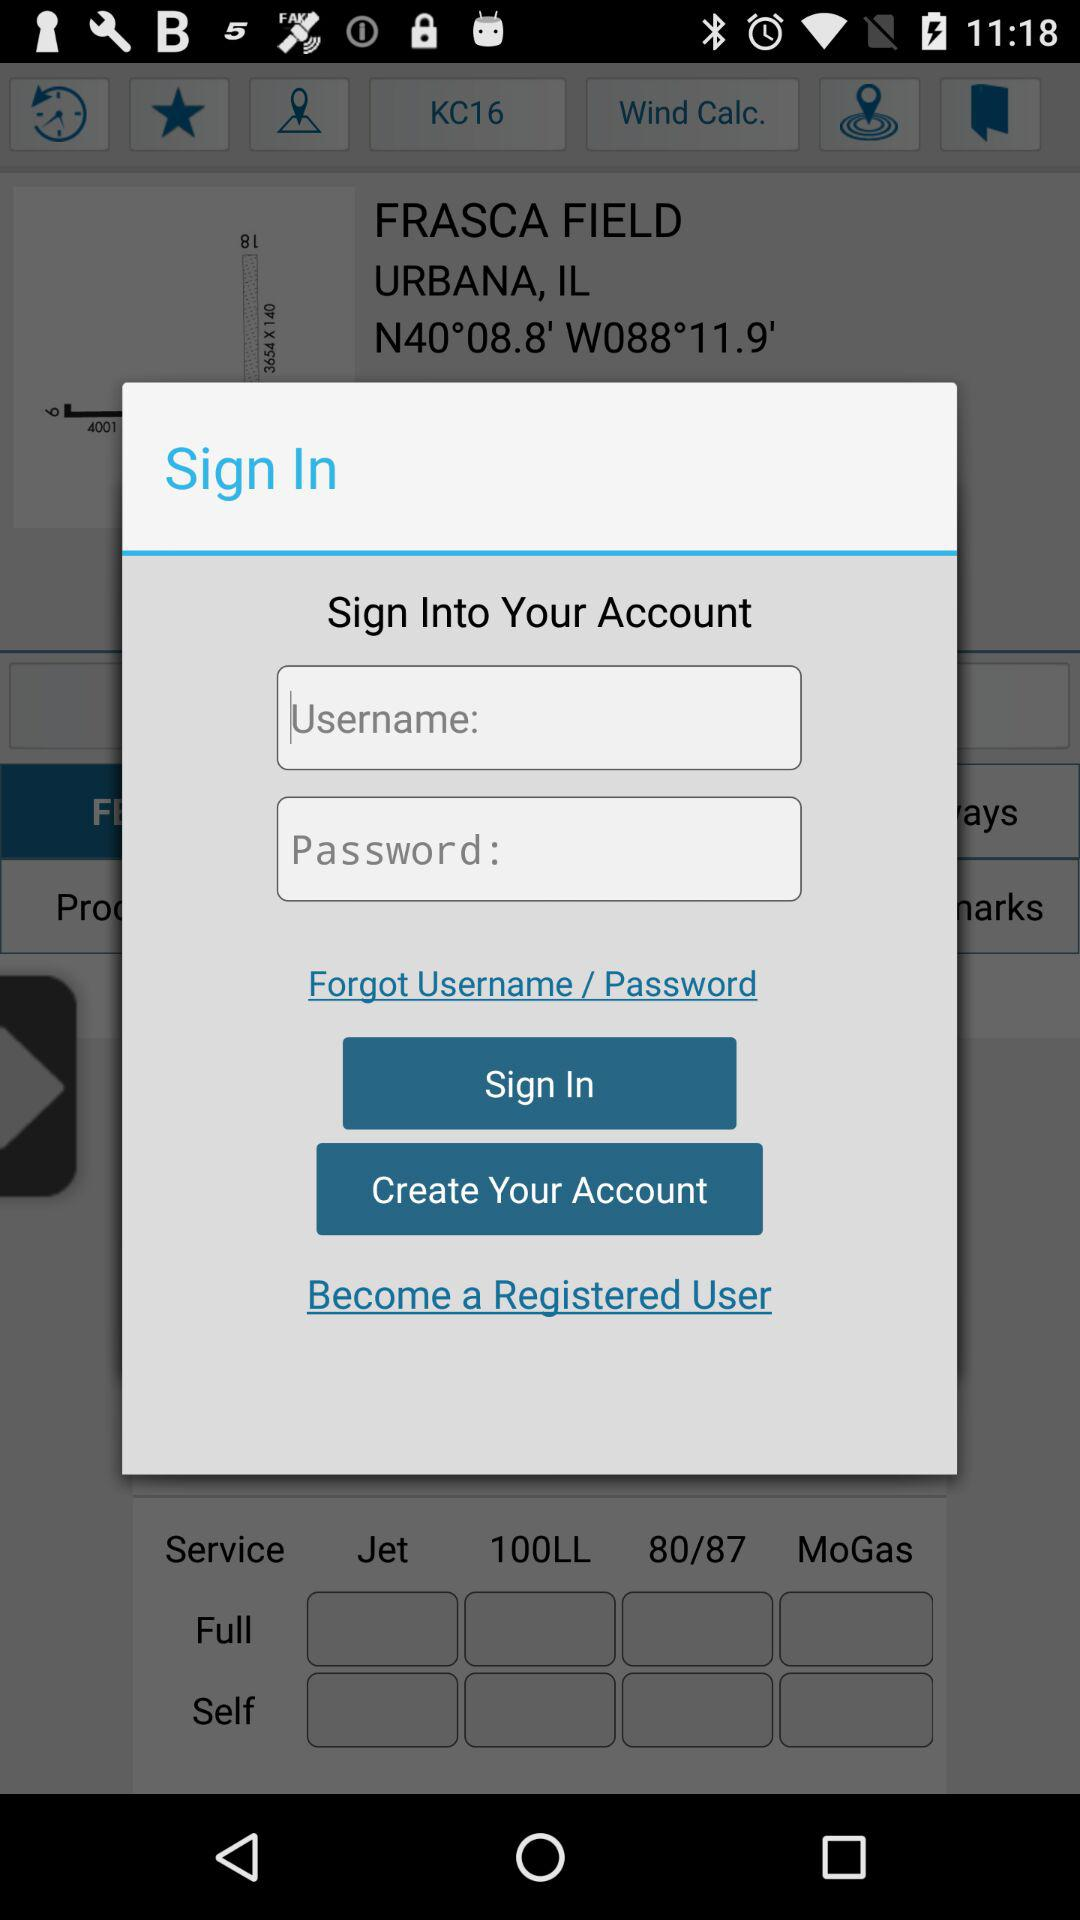How many text inputs are in the sign in form?
Answer the question using a single word or phrase. 2 